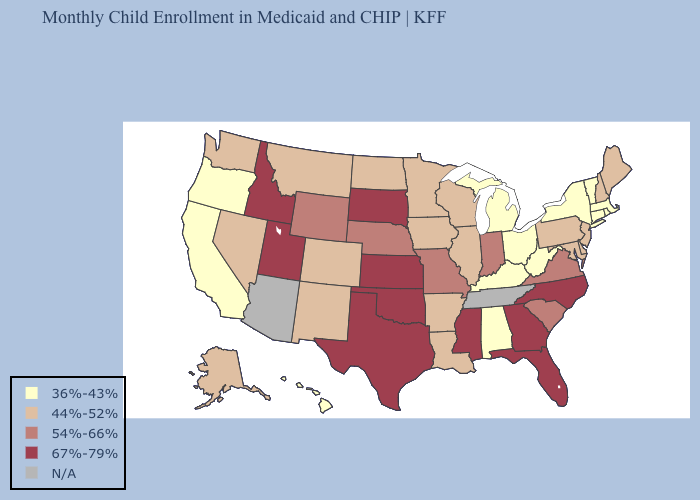Among the states that border Kansas , which have the highest value?
Short answer required. Oklahoma. What is the lowest value in the West?
Keep it brief. 36%-43%. Among the states that border Utah , does Idaho have the highest value?
Answer briefly. Yes. Name the states that have a value in the range 67%-79%?
Answer briefly. Florida, Georgia, Idaho, Kansas, Mississippi, North Carolina, Oklahoma, South Dakota, Texas, Utah. Name the states that have a value in the range 44%-52%?
Give a very brief answer. Alaska, Arkansas, Colorado, Delaware, Illinois, Iowa, Louisiana, Maine, Maryland, Minnesota, Montana, Nevada, New Hampshire, New Jersey, New Mexico, North Dakota, Pennsylvania, Washington, Wisconsin. Among the states that border Florida , does Georgia have the highest value?
Keep it brief. Yes. What is the value of North Carolina?
Give a very brief answer. 67%-79%. Name the states that have a value in the range 54%-66%?
Short answer required. Indiana, Missouri, Nebraska, South Carolina, Virginia, Wyoming. Does New York have the highest value in the USA?
Keep it brief. No. Which states have the highest value in the USA?
Answer briefly. Florida, Georgia, Idaho, Kansas, Mississippi, North Carolina, Oklahoma, South Dakota, Texas, Utah. What is the value of Wyoming?
Short answer required. 54%-66%. What is the value of Alaska?
Be succinct. 44%-52%. Name the states that have a value in the range 36%-43%?
Write a very short answer. Alabama, California, Connecticut, Hawaii, Kentucky, Massachusetts, Michigan, New York, Ohio, Oregon, Rhode Island, Vermont, West Virginia. Does Utah have the lowest value in the USA?
Write a very short answer. No. What is the highest value in the USA?
Keep it brief. 67%-79%. 